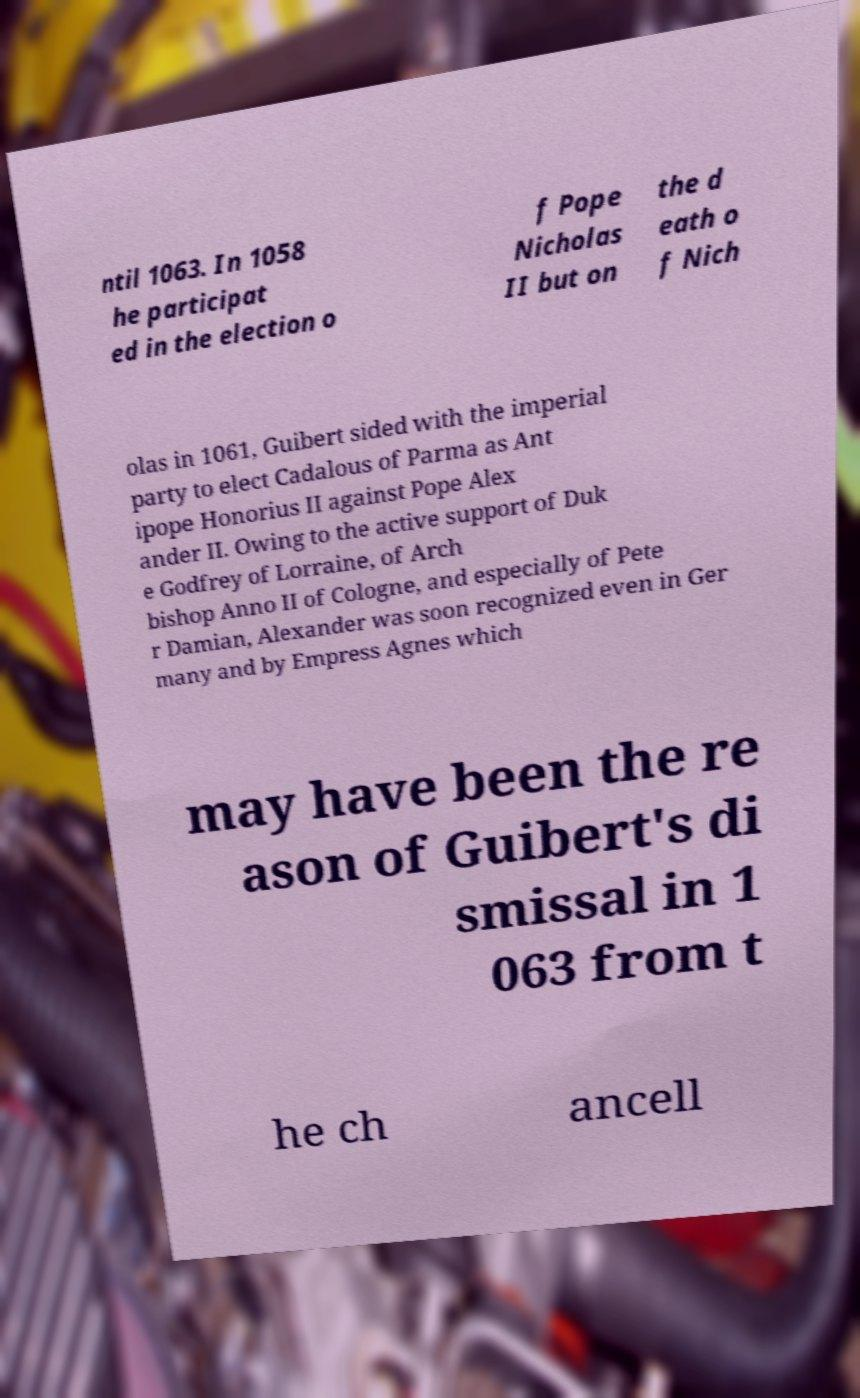I need the written content from this picture converted into text. Can you do that? ntil 1063. In 1058 he participat ed in the election o f Pope Nicholas II but on the d eath o f Nich olas in 1061, Guibert sided with the imperial party to elect Cadalous of Parma as Ant ipope Honorius II against Pope Alex ander II. Owing to the active support of Duk e Godfrey of Lorraine, of Arch bishop Anno II of Cologne, and especially of Pete r Damian, Alexander was soon recognized even in Ger many and by Empress Agnes which may have been the re ason of Guibert's di smissal in 1 063 from t he ch ancell 